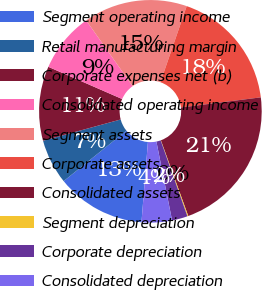Convert chart. <chart><loc_0><loc_0><loc_500><loc_500><pie_chart><fcel>Segment operating income<fcel>Retail manufacturing margin<fcel>Corporate expenses net (b)<fcel>Consolidated operating income<fcel>Segment assets<fcel>Corporate assets<fcel>Consolidated assets<fcel>Segment depreciation<fcel>Corporate depreciation<fcel>Consolidated depreciation<nl><fcel>12.94%<fcel>6.53%<fcel>10.8%<fcel>8.67%<fcel>15.07%<fcel>17.71%<fcel>21.48%<fcel>0.13%<fcel>2.27%<fcel>4.4%<nl></chart> 